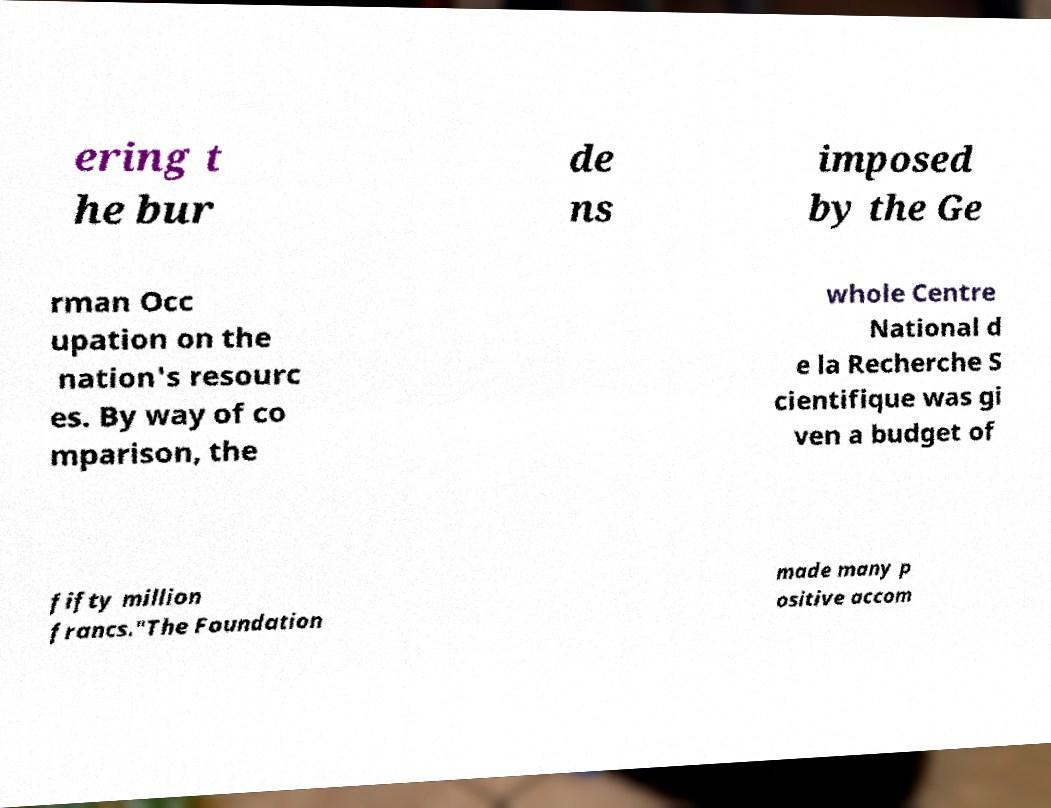For documentation purposes, I need the text within this image transcribed. Could you provide that? ering t he bur de ns imposed by the Ge rman Occ upation on the nation's resourc es. By way of co mparison, the whole Centre National d e la Recherche S cientifique was gi ven a budget of fifty million francs."The Foundation made many p ositive accom 